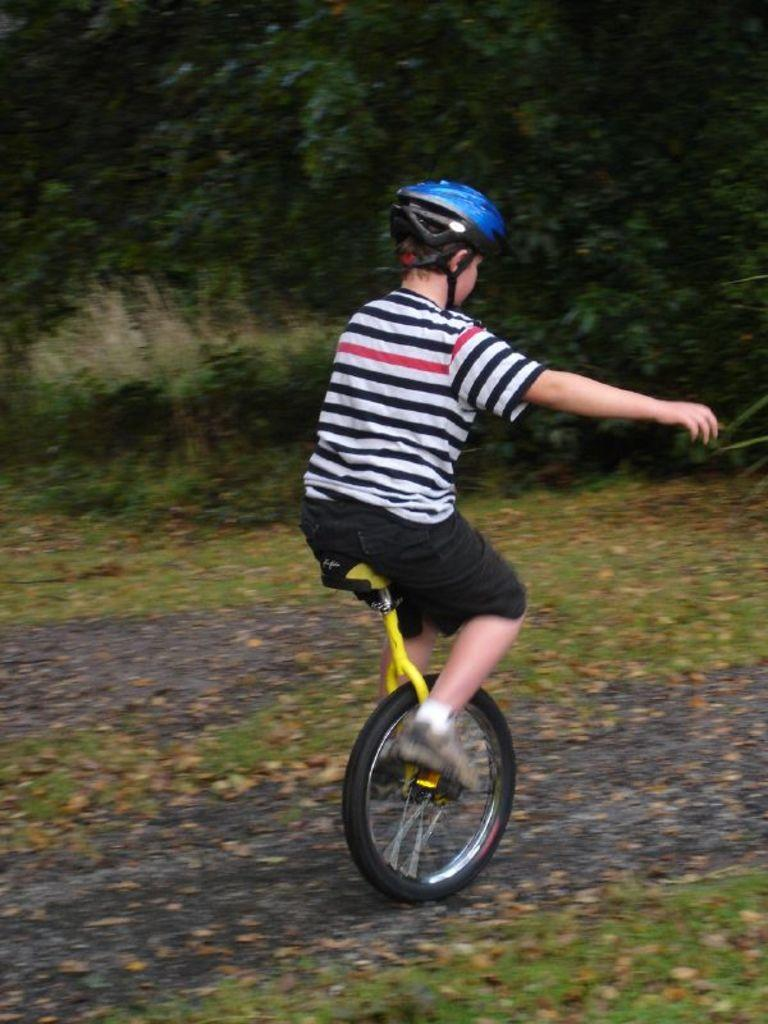What is the person in the image doing? The person is riding a unicycle. What type of environment is the person in? There are trees behind the person and grass visible in the image, suggesting a natural setting. What type of stocking is the person wearing while riding the unicycle? There is no mention of stockings in the image, so it cannot be determined if the person is wearing any. 